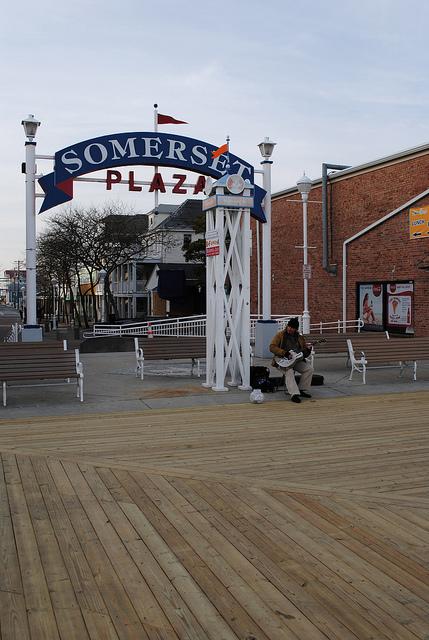Are people riding bikes?
Concise answer only. No. What is the name of the Plaza?
Quick response, please. Somerset. Is someone sitting on the bench?
Keep it brief. Yes. What is the scenery?
Answer briefly. Somerset plaza. 